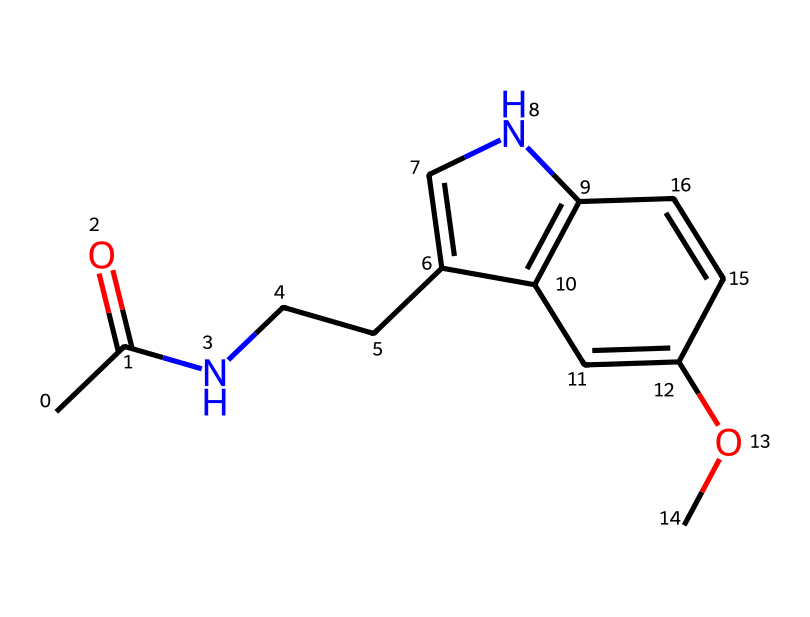What is the molecular formula of this compound? To find the molecular formula, count the different types of atoms present in the SMILES representation. For this compound, it has 13 carbon atoms (C), 16 hydrogen atoms (H), 2 nitrogen atoms (N), and 3 oxygen atoms (O). So, the molecular formula is C13H16N2O3.
Answer: C13H16N2O3 How many rings are present in the chemical structure? When examining the SMILES representation, look for sections that indicate cyclic structures. The presence of '1' and '2' designates ring closures, revealing two rings in the compound.
Answer: 2 What type of functional groups are present in this molecule? Analyzing the SMILES indicates the presence of an acetamide group (CC(=O)N) and a methoxy group (OC). The functional groups contribute to the molecule’s properties.
Answer: acetamide, methoxy What does the presence of nitrogen atoms imply about the biological activity? The presence of nitrogen atoms typically suggests that the compound may have pharmacological effects, particularly in neurotransmission or as a neurohormone because many important neurotransmitters contain nitrogen.
Answer: pharmacological activity How does the structure relate to melatonin's function in sleep regulation? Melatonin, a hormone, is synthesized from serotonin, which has a similar structure. The structure contains an indole ring and an acetamide group; these features are crucial for melatonin’s interaction with melatonin receptors in the brain that regulate sleep.
Answer: interacts with receptors 